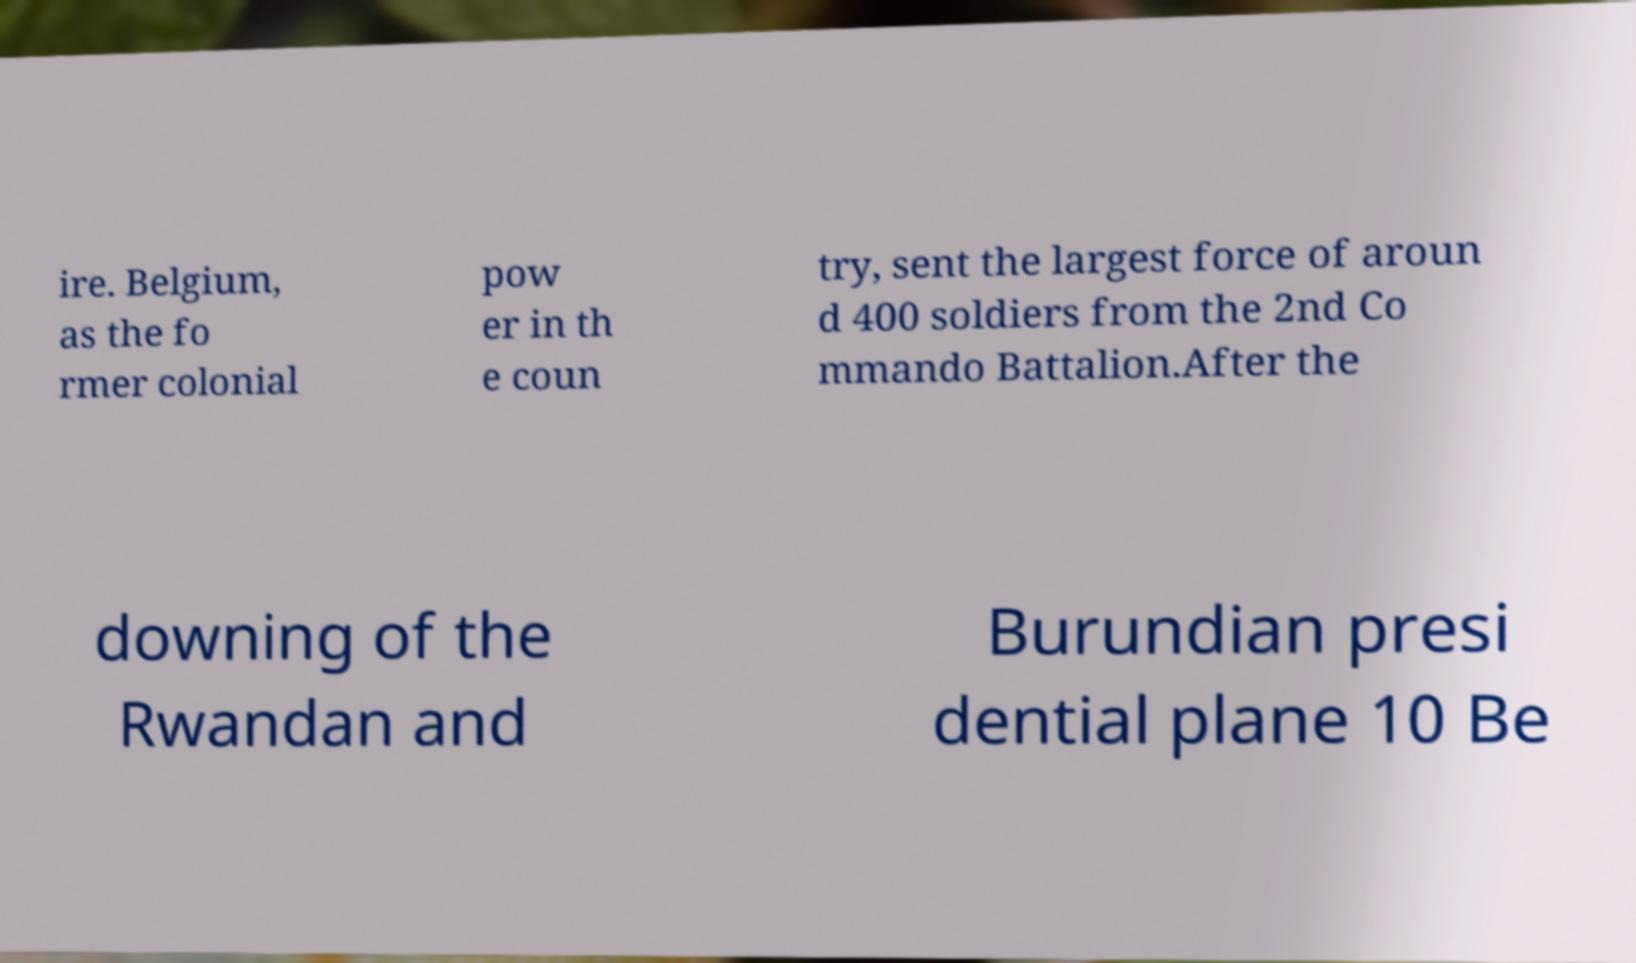Can you accurately transcribe the text from the provided image for me? ire. Belgium, as the fo rmer colonial pow er in th e coun try, sent the largest force of aroun d 400 soldiers from the 2nd Co mmando Battalion.After the downing of the Rwandan and Burundian presi dential plane 10 Be 